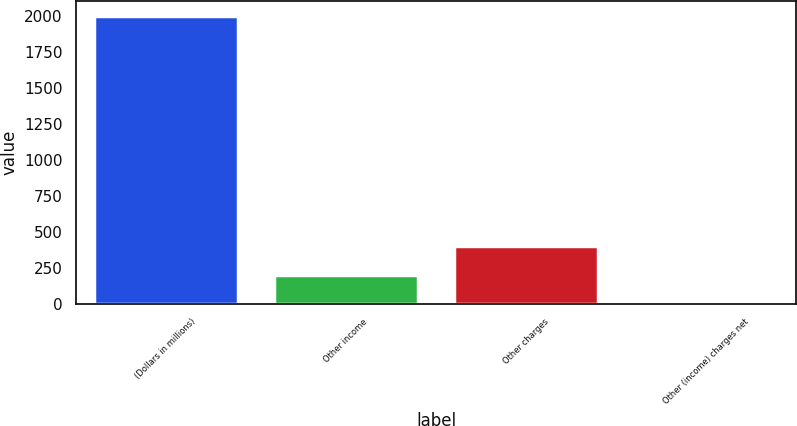Convert chart to OTSL. <chart><loc_0><loc_0><loc_500><loc_500><bar_chart><fcel>(Dollars in millions)<fcel>Other income<fcel>Other charges<fcel>Other (income) charges net<nl><fcel>2002<fcel>202<fcel>402<fcel>2<nl></chart> 